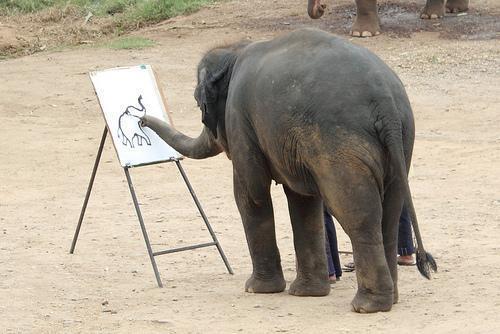How many elephants are in the picture?
Give a very brief answer. 1. 